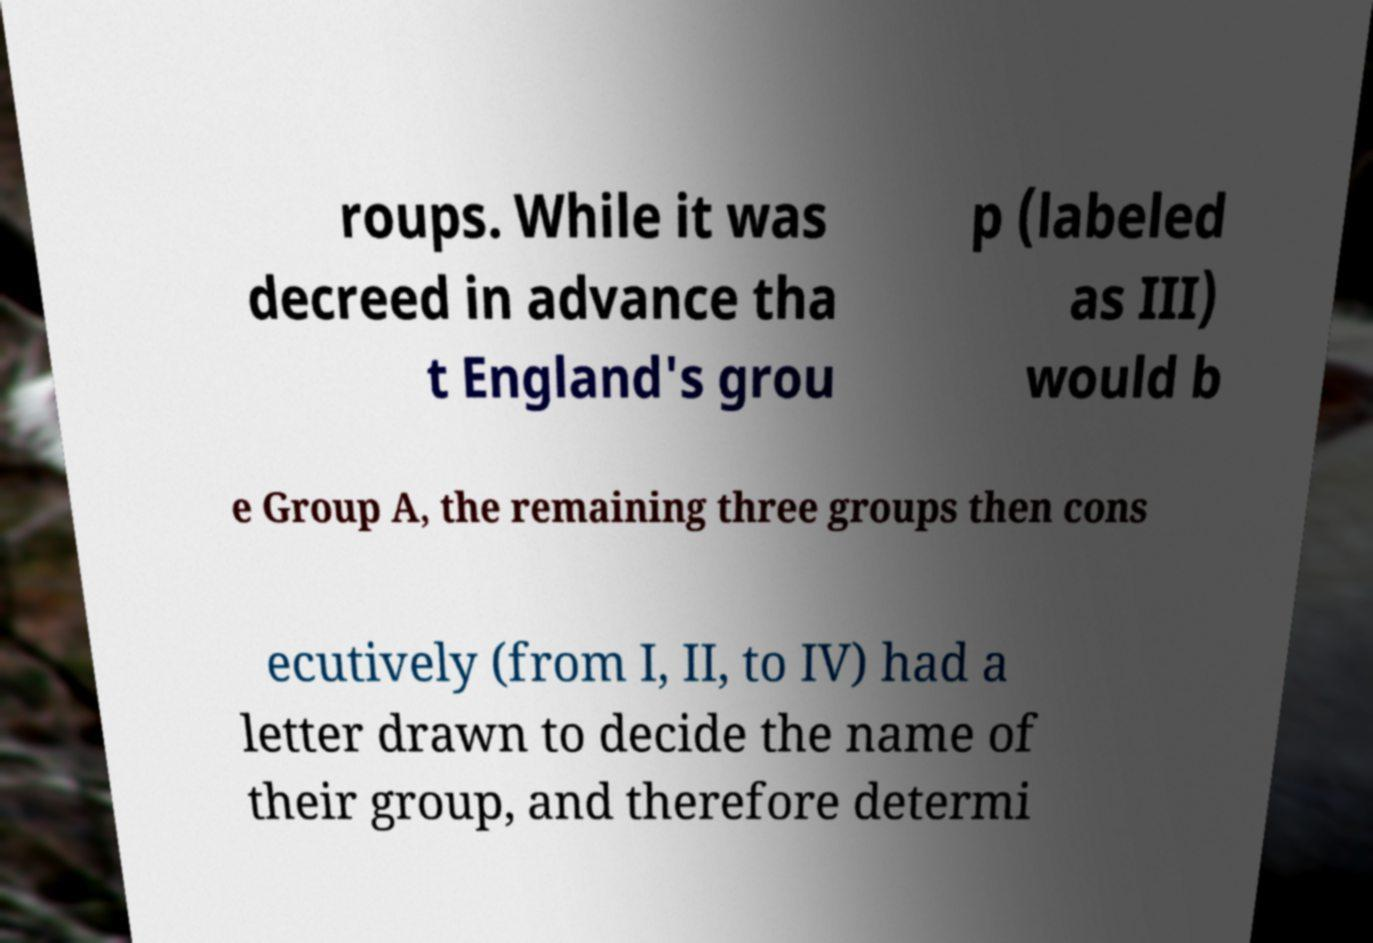Please identify and transcribe the text found in this image. roups. While it was decreed in advance tha t England's grou p (labeled as III) would b e Group A, the remaining three groups then cons ecutively (from I, II, to IV) had a letter drawn to decide the name of their group, and therefore determi 